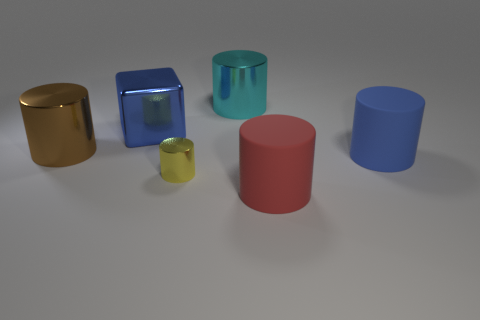What size is the cylinder that is the same color as the big metal block?
Provide a short and direct response. Large. There is a large metal cylinder to the right of the yellow metallic cylinder; how many yellow shiny things are in front of it?
Your answer should be compact. 1. How many big shiny objects are both to the left of the yellow thing and on the right side of the brown metallic thing?
Give a very brief answer. 1. What number of objects are cyan spheres or large matte things right of the red object?
Ensure brevity in your answer.  1. What is the size of the cyan cylinder that is made of the same material as the large cube?
Your answer should be compact. Large. What is the shape of the large blue thing to the left of the metal cylinder that is behind the brown cylinder?
Your response must be concise. Cube. How many purple things are large matte objects or metal things?
Give a very brief answer. 0. Are there any yellow metallic cylinders behind the big blue thing that is on the right side of the block in front of the big cyan shiny cylinder?
Your answer should be very brief. No. There is a large object that is the same color as the large shiny cube; what is its shape?
Offer a terse response. Cylinder. What number of big objects are blue matte balls or rubber cylinders?
Offer a very short reply. 2. 